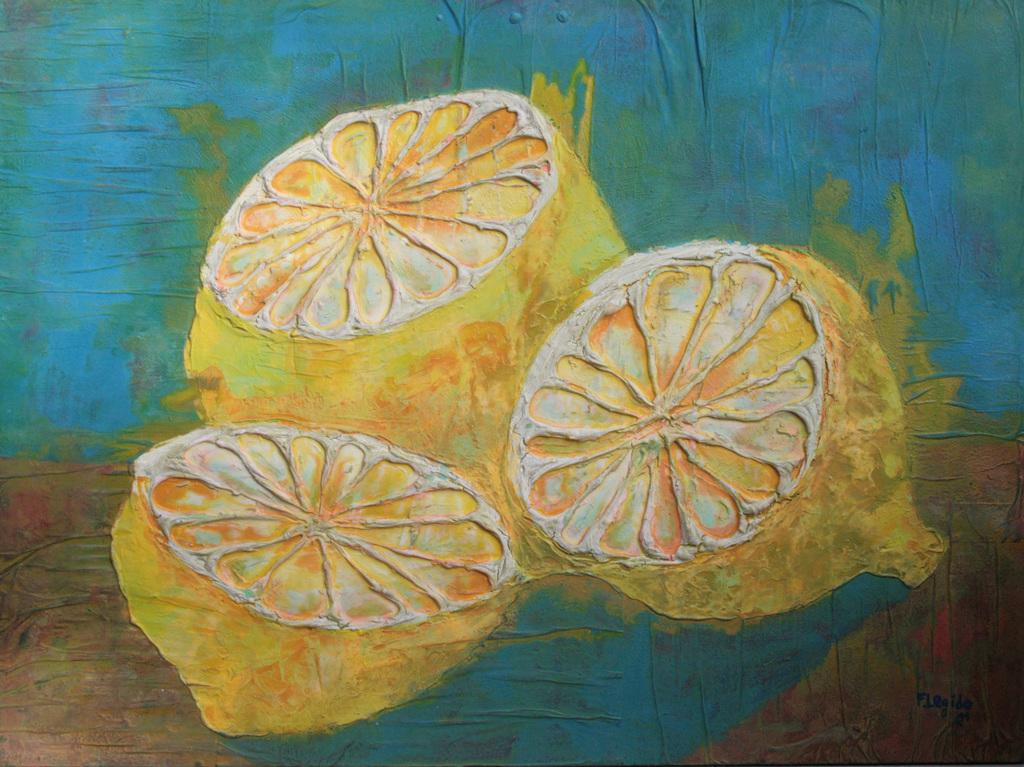What is the main subject of the painting? The painting depicts lemons. What color are the lemons in the painting? The lemons are in yellow color. What colors can be seen in the background of the painting? The background of the painting includes blue and brown colors. How many sisters are depicted in the painting? There are no sisters depicted in the painting; it features lemons and a background with blue and brown colors. Is there a bear visible in the painting? There is no bear present in the painting; it only depicts lemons and a background with blue and brown colors. 